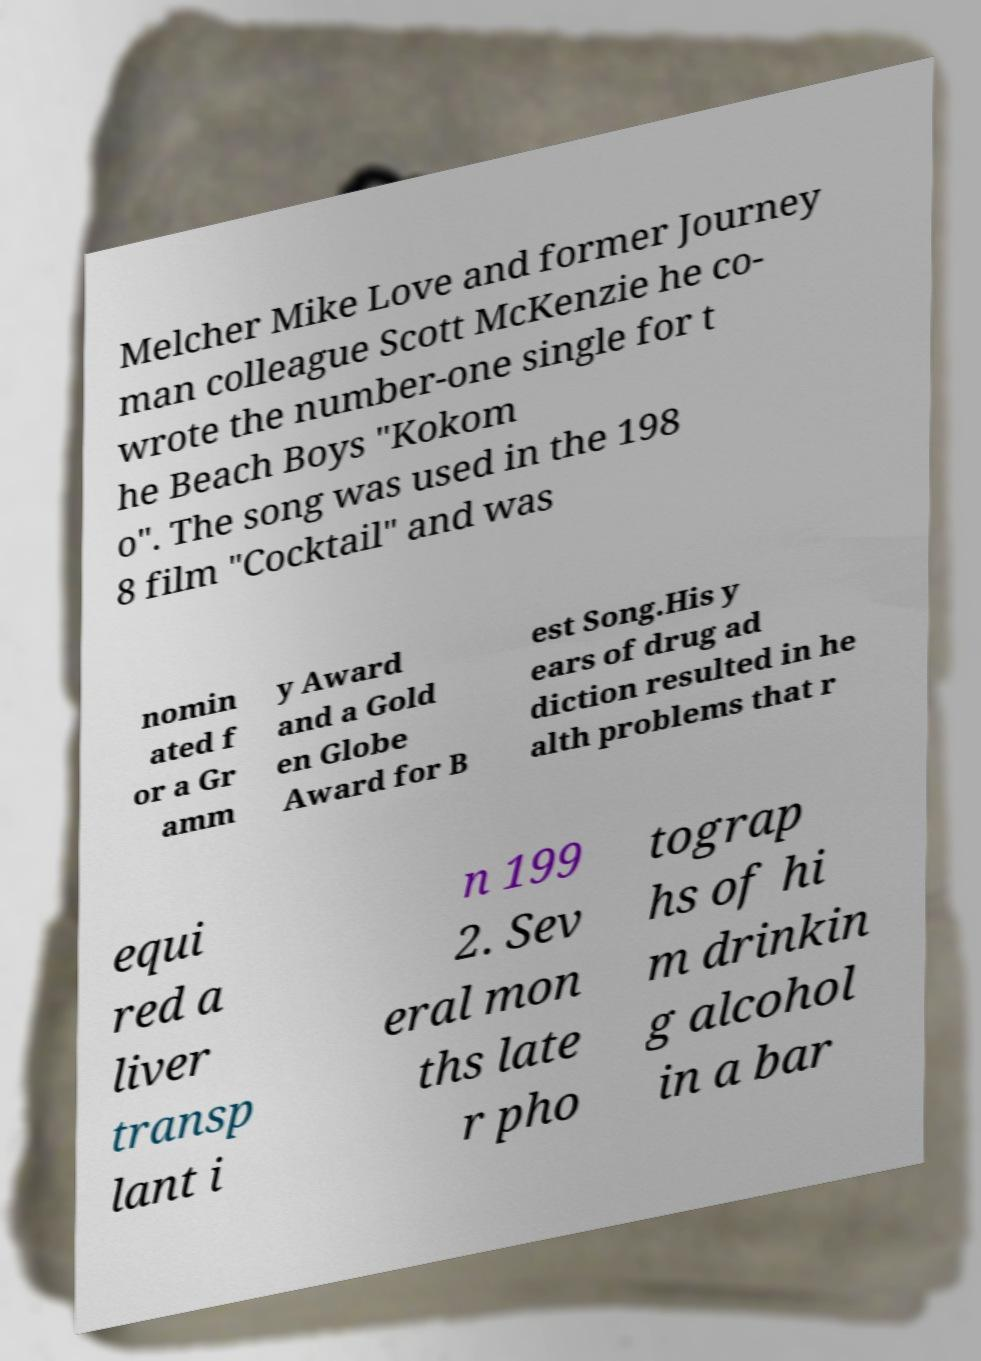Can you read and provide the text displayed in the image?This photo seems to have some interesting text. Can you extract and type it out for me? Melcher Mike Love and former Journey man colleague Scott McKenzie he co- wrote the number-one single for t he Beach Boys "Kokom o". The song was used in the 198 8 film "Cocktail" and was nomin ated f or a Gr amm y Award and a Gold en Globe Award for B est Song.His y ears of drug ad diction resulted in he alth problems that r equi red a liver transp lant i n 199 2. Sev eral mon ths late r pho tograp hs of hi m drinkin g alcohol in a bar 